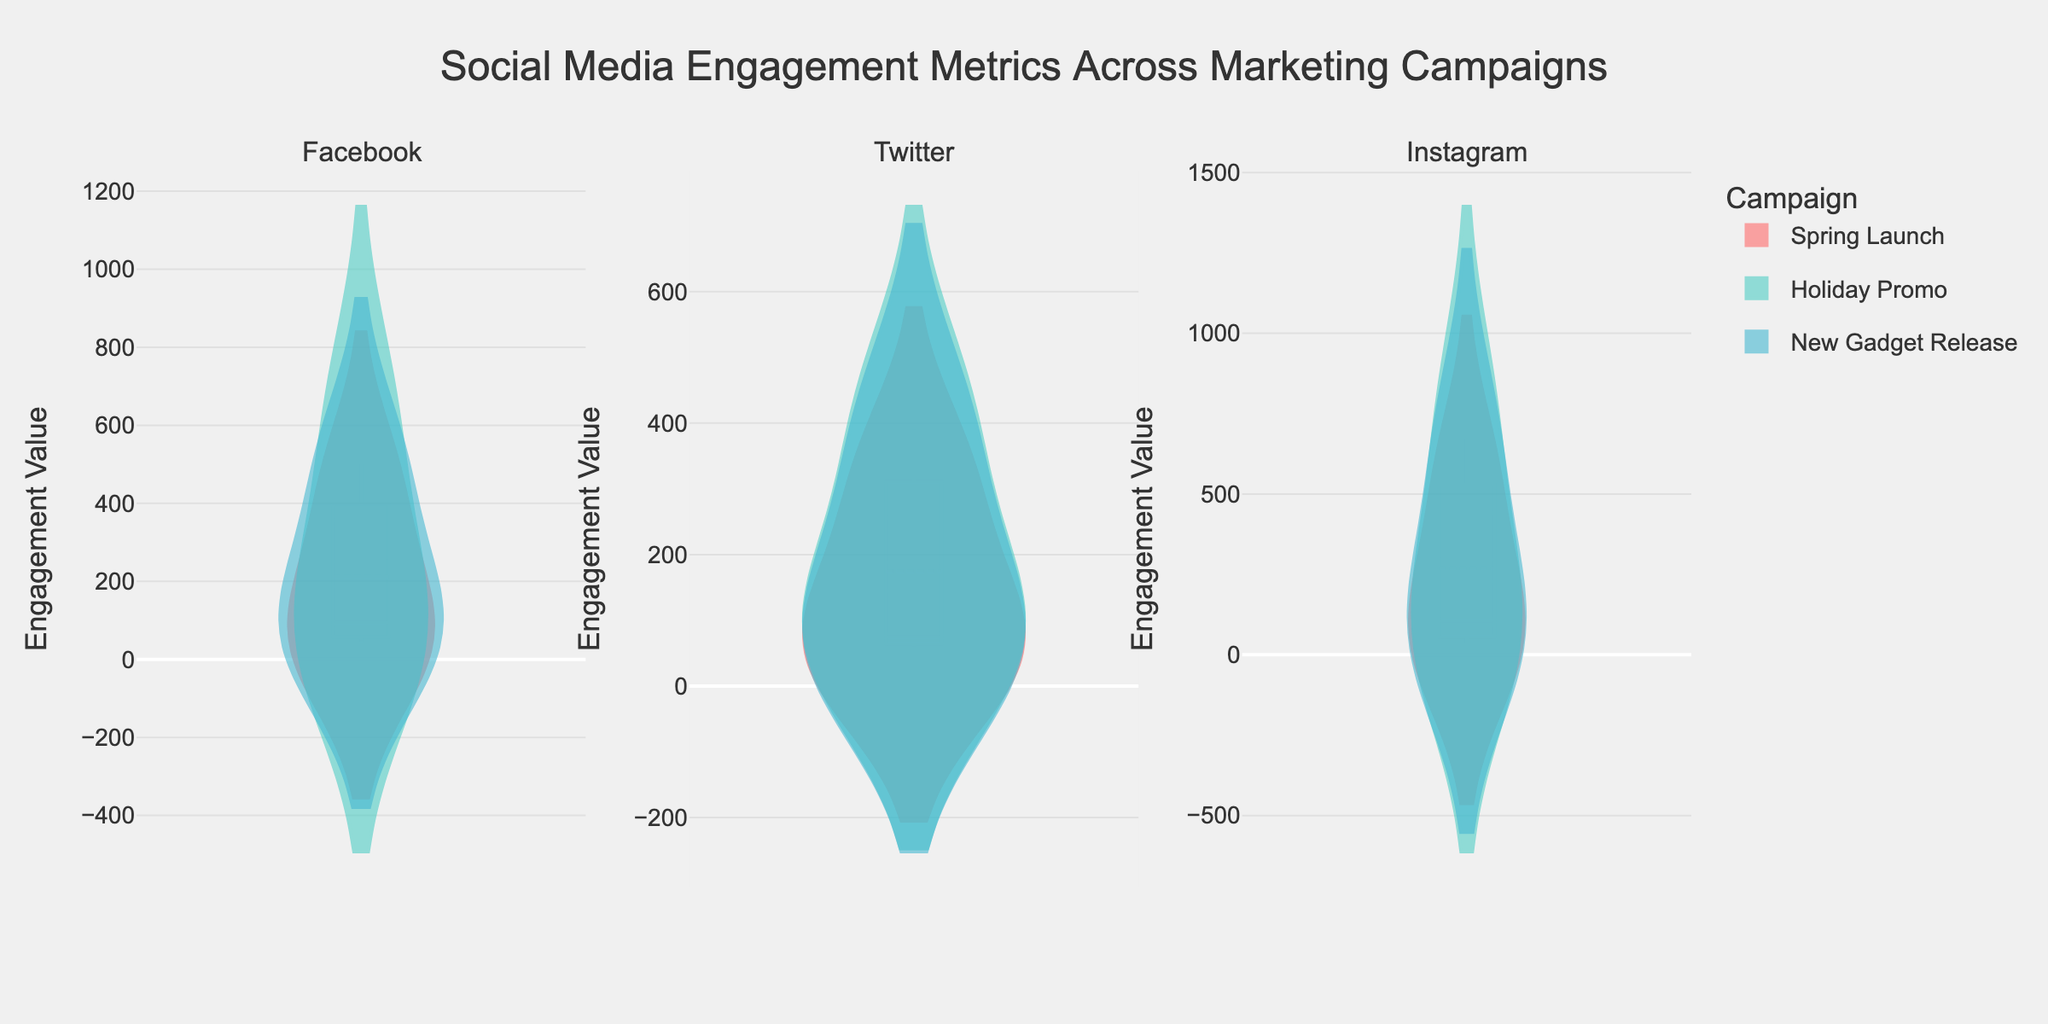What is the title of the figure? The title is prominently displayed at the top center of the figure.
Answer: Social Media Engagement Metrics Across Marketing Campaigns Which platform has the highest median engagement value during the Holiday Promo campaign? By analyzing the violin plots, we can observe that for the Holiday Promo campaign, Instagram has the highest median engagement value.
Answer: Instagram How do the engagement metrics of the Spring Launch campaign compare across different platforms? By looking at the violin plots, the median engagement values and distributions can be compared. Facebook and Instagram show higher values and wider distributions compared to Twitter.
Answer: Facebook and Instagram have higher engagement values compared to Twitter What is the difference between the median engagement values of Instagram and Facebook for the New Gadget Release campaign? For the New Gadget Release campaign, the violin plots indicate that Instagram's median is higher than Facebook's. The difference can be observed directly from the median lines within the plots.
Answer: Difference is noticeable, Instagram is higher Which platform shows the most spread-out distribution of engagement values for the Holiday Promo campaign? By examining the spreads of the violin plots, Facebook shows the most spread-out distribution for the Holiday Promo campaign.
Answer: Facebook How can one identify the least popular platform for any given campaign in the figure? The least popular platform can be identified by looking at the shorter and less spread-out violin plots, which indicate fewer and lower engagement values.
Answer: By looking at the shortest, least spread-out violin plots Compare the median engagement value for Twitter across the three campaigns. Which campaign has the highest median? By observing the median lines in the violin plots for Twitter, the Holiday Promo campaign shows the highest median engagement value.
Answer: Holiday Promo Which campaign on Instagram shows the least spread in engagement values? The least spread can be determined by the narrowest violin plot. For Instagram, the Spring Launch campaign shows the narrowest distribution.
Answer: Spring Launch Are there any campaigns where all the platforms have similar engagement distributions? By comparing the shapes and spreads of the plots, the New Gadget Release campaign shows somewhat similar engagement distributions for Facebook, Twitter, and Instagram.
Answer: New Gadget Release How does the spread of engagement values for Facebook's New Gadget Release campaign compare to Twitter's same campaign? By comparing the widths of the violin plots, Facebook shows a broader spread of engagement values compared to Twitter for the New Gadget Release campaign.
Answer: Facebook has a broader spread than Twitter 